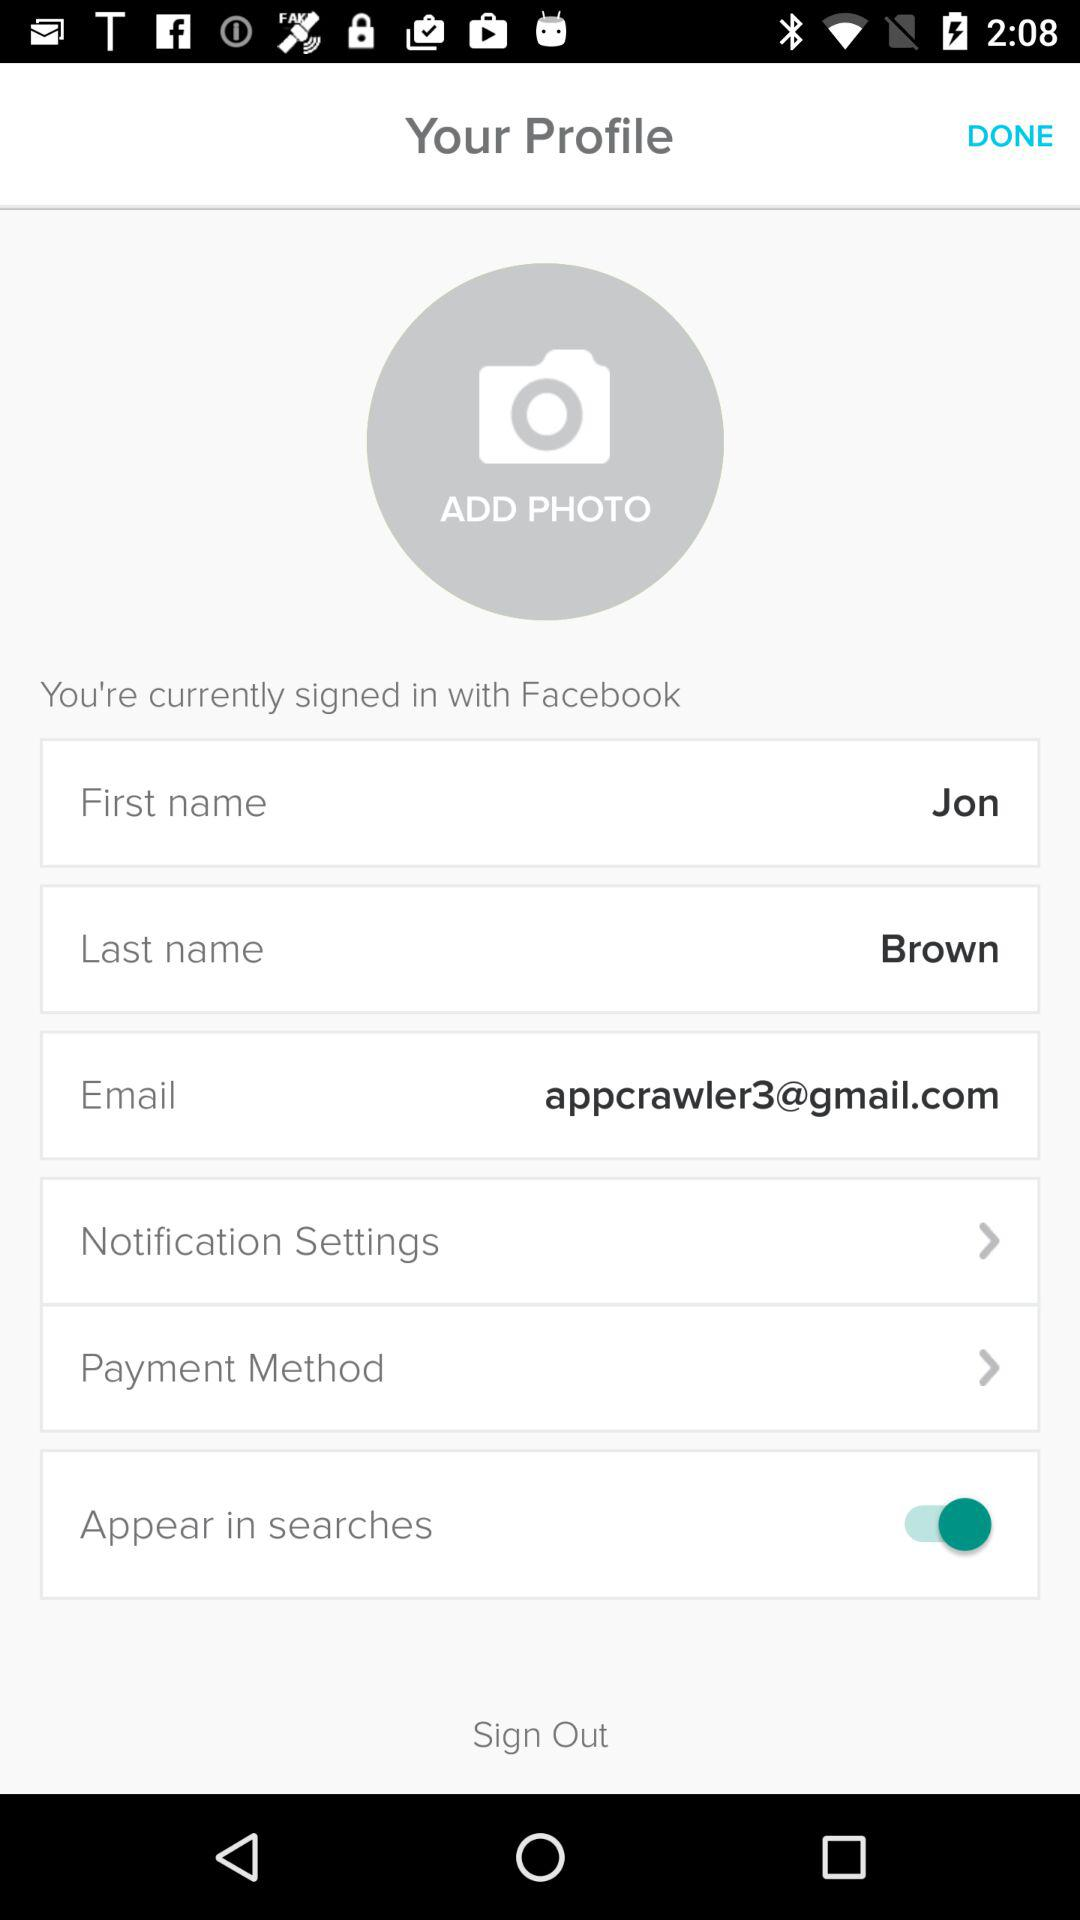What is the name of the user? The name of the user is Jon Brown. 